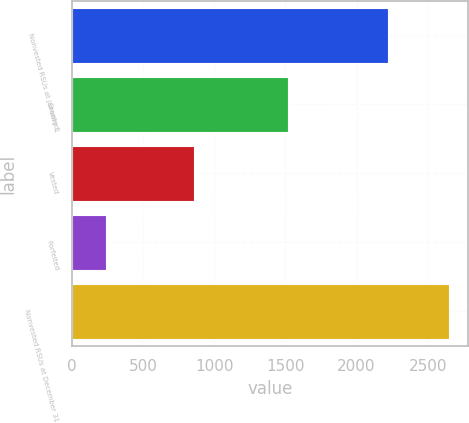Convert chart. <chart><loc_0><loc_0><loc_500><loc_500><bar_chart><fcel>Nonvested RSUs at January 1<fcel>Granted<fcel>Vested<fcel>Forfeited<fcel>Nonvested RSUs at December 31<nl><fcel>2218<fcel>1521<fcel>854<fcel>237<fcel>2648<nl></chart> 